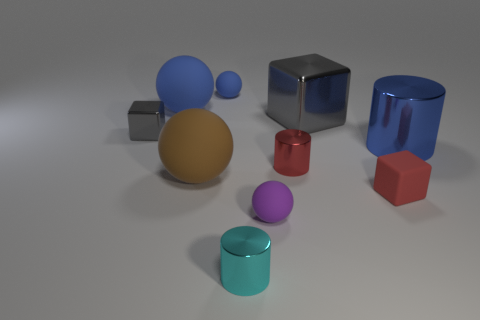Subtract all cylinders. How many objects are left? 7 Subtract 0 purple cylinders. How many objects are left? 10 Subtract all small metal cubes. Subtract all large things. How many objects are left? 5 Add 4 large gray metallic blocks. How many large gray metallic blocks are left? 5 Add 4 blue spheres. How many blue spheres exist? 6 